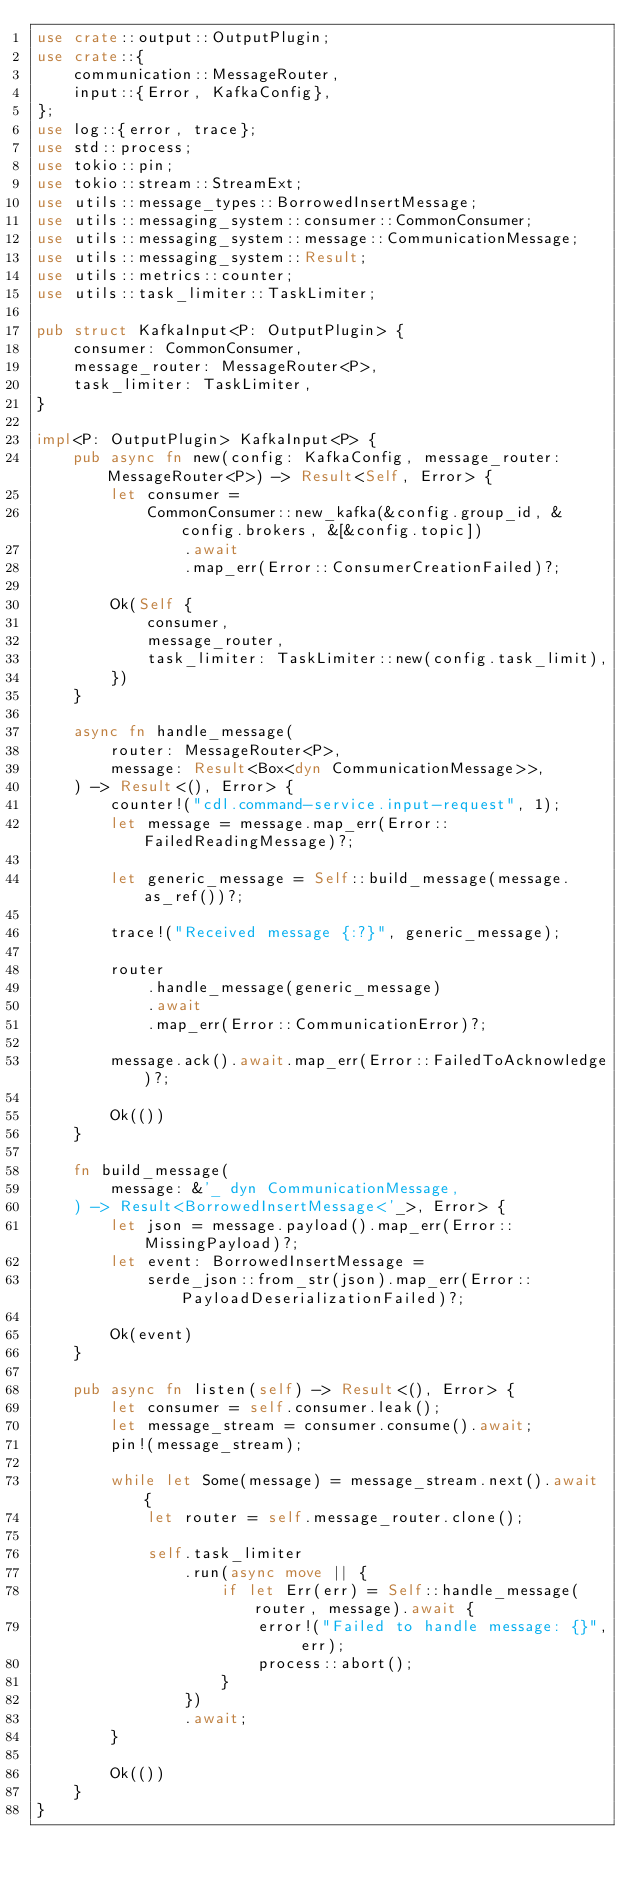<code> <loc_0><loc_0><loc_500><loc_500><_Rust_>use crate::output::OutputPlugin;
use crate::{
    communication::MessageRouter,
    input::{Error, KafkaConfig},
};
use log::{error, trace};
use std::process;
use tokio::pin;
use tokio::stream::StreamExt;
use utils::message_types::BorrowedInsertMessage;
use utils::messaging_system::consumer::CommonConsumer;
use utils::messaging_system::message::CommunicationMessage;
use utils::messaging_system::Result;
use utils::metrics::counter;
use utils::task_limiter::TaskLimiter;

pub struct KafkaInput<P: OutputPlugin> {
    consumer: CommonConsumer,
    message_router: MessageRouter<P>,
    task_limiter: TaskLimiter,
}

impl<P: OutputPlugin> KafkaInput<P> {
    pub async fn new(config: KafkaConfig, message_router: MessageRouter<P>) -> Result<Self, Error> {
        let consumer =
            CommonConsumer::new_kafka(&config.group_id, &config.brokers, &[&config.topic])
                .await
                .map_err(Error::ConsumerCreationFailed)?;

        Ok(Self {
            consumer,
            message_router,
            task_limiter: TaskLimiter::new(config.task_limit),
        })
    }

    async fn handle_message(
        router: MessageRouter<P>,
        message: Result<Box<dyn CommunicationMessage>>,
    ) -> Result<(), Error> {
        counter!("cdl.command-service.input-request", 1);
        let message = message.map_err(Error::FailedReadingMessage)?;

        let generic_message = Self::build_message(message.as_ref())?;

        trace!("Received message {:?}", generic_message);

        router
            .handle_message(generic_message)
            .await
            .map_err(Error::CommunicationError)?;

        message.ack().await.map_err(Error::FailedToAcknowledge)?;

        Ok(())
    }

    fn build_message(
        message: &'_ dyn CommunicationMessage,
    ) -> Result<BorrowedInsertMessage<'_>, Error> {
        let json = message.payload().map_err(Error::MissingPayload)?;
        let event: BorrowedInsertMessage =
            serde_json::from_str(json).map_err(Error::PayloadDeserializationFailed)?;

        Ok(event)
    }

    pub async fn listen(self) -> Result<(), Error> {
        let consumer = self.consumer.leak();
        let message_stream = consumer.consume().await;
        pin!(message_stream);

        while let Some(message) = message_stream.next().await {
            let router = self.message_router.clone();

            self.task_limiter
                .run(async move || {
                    if let Err(err) = Self::handle_message(router, message).await {
                        error!("Failed to handle message: {}", err);
                        process::abort();
                    }
                })
                .await;
        }

        Ok(())
    }
}
</code> 